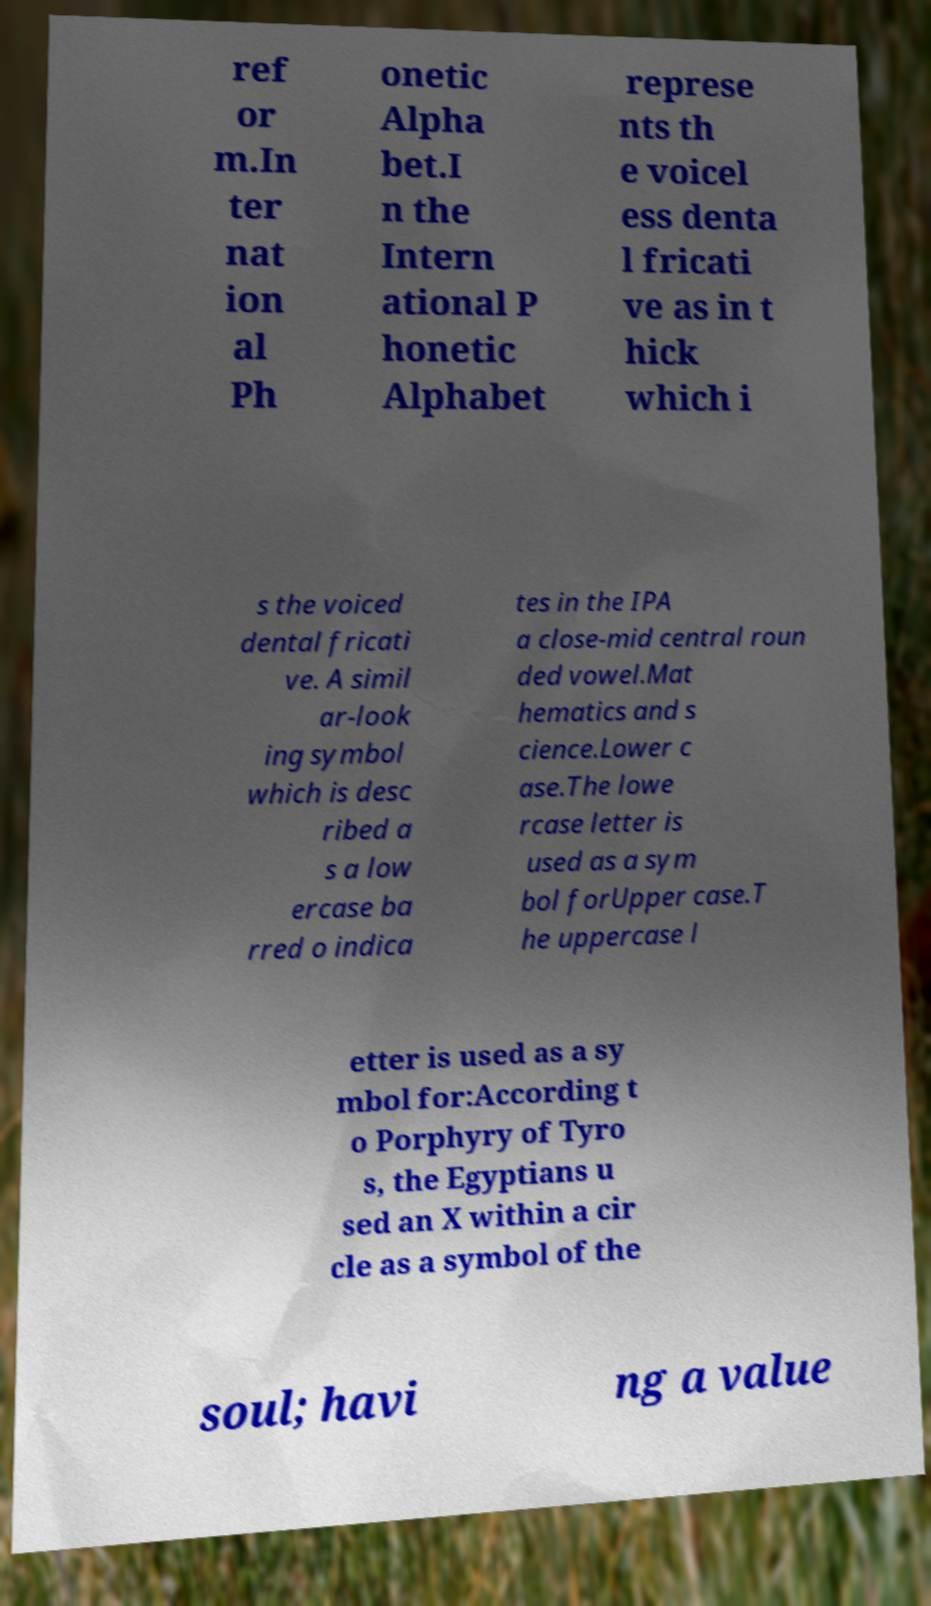For documentation purposes, I need the text within this image transcribed. Could you provide that? ref or m.In ter nat ion al Ph onetic Alpha bet.I n the Intern ational P honetic Alphabet represe nts th e voicel ess denta l fricati ve as in t hick which i s the voiced dental fricati ve. A simil ar-look ing symbol which is desc ribed a s a low ercase ba rred o indica tes in the IPA a close-mid central roun ded vowel.Mat hematics and s cience.Lower c ase.The lowe rcase letter is used as a sym bol forUpper case.T he uppercase l etter is used as a sy mbol for:According t o Porphyry of Tyro s, the Egyptians u sed an X within a cir cle as a symbol of the soul; havi ng a value 